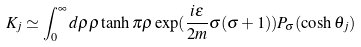<formula> <loc_0><loc_0><loc_500><loc_500>K _ { j } \simeq \int _ { 0 } ^ { \infty } d \rho \rho \tanh \pi \rho \exp ( \frac { i \varepsilon } { 2 m } \sigma ( \sigma + 1 ) ) P _ { \sigma } ( \cosh \theta _ { j } )</formula> 